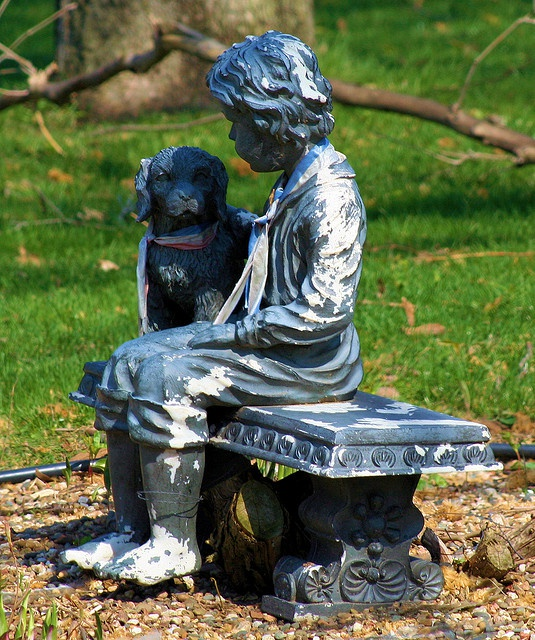Describe the objects in this image and their specific colors. I can see people in darkgreen, black, white, and gray tones, bench in darkgreen, black, and gray tones, and dog in darkgreen, black, navy, blue, and gray tones in this image. 